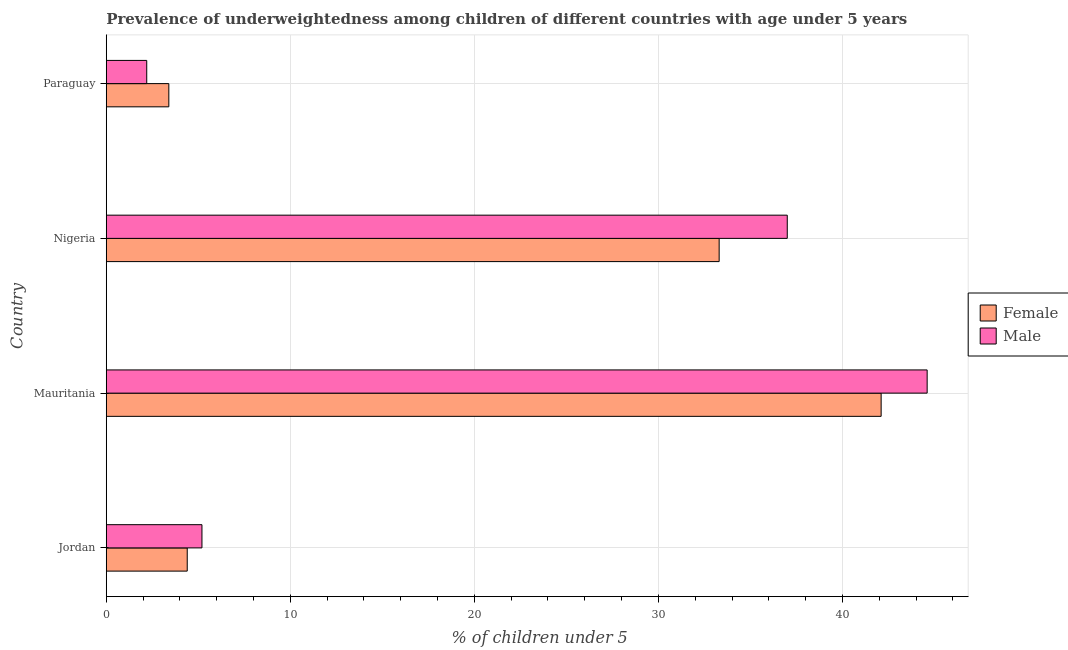What is the label of the 4th group of bars from the top?
Your answer should be compact. Jordan. What is the percentage of underweighted female children in Paraguay?
Give a very brief answer. 3.4. Across all countries, what is the maximum percentage of underweighted female children?
Offer a very short reply. 42.1. Across all countries, what is the minimum percentage of underweighted female children?
Make the answer very short. 3.4. In which country was the percentage of underweighted female children maximum?
Provide a short and direct response. Mauritania. In which country was the percentage of underweighted female children minimum?
Offer a very short reply. Paraguay. What is the total percentage of underweighted male children in the graph?
Offer a very short reply. 89. What is the difference between the percentage of underweighted female children in Jordan and that in Nigeria?
Offer a terse response. -28.9. What is the difference between the percentage of underweighted male children in Jordan and the percentage of underweighted female children in Mauritania?
Provide a succinct answer. -36.9. What is the average percentage of underweighted male children per country?
Offer a terse response. 22.25. In how many countries, is the percentage of underweighted male children greater than 32 %?
Your answer should be compact. 2. What is the ratio of the percentage of underweighted male children in Nigeria to that in Paraguay?
Ensure brevity in your answer.  16.82. Is the percentage of underweighted male children in Jordan less than that in Paraguay?
Your response must be concise. No. What is the difference between the highest and the lowest percentage of underweighted female children?
Offer a very short reply. 38.7. In how many countries, is the percentage of underweighted female children greater than the average percentage of underweighted female children taken over all countries?
Offer a terse response. 2. What does the 1st bar from the top in Jordan represents?
Your answer should be compact. Male. Are all the bars in the graph horizontal?
Give a very brief answer. Yes. How many countries are there in the graph?
Ensure brevity in your answer.  4. Does the graph contain grids?
Offer a very short reply. Yes. Where does the legend appear in the graph?
Your answer should be very brief. Center right. How many legend labels are there?
Make the answer very short. 2. How are the legend labels stacked?
Give a very brief answer. Vertical. What is the title of the graph?
Ensure brevity in your answer.  Prevalence of underweightedness among children of different countries with age under 5 years. Does "Primary income" appear as one of the legend labels in the graph?
Ensure brevity in your answer.  No. What is the label or title of the X-axis?
Your answer should be very brief.  % of children under 5. What is the  % of children under 5 of Female in Jordan?
Make the answer very short. 4.4. What is the  % of children under 5 of Male in Jordan?
Your response must be concise. 5.2. What is the  % of children under 5 of Female in Mauritania?
Give a very brief answer. 42.1. What is the  % of children under 5 of Male in Mauritania?
Offer a very short reply. 44.6. What is the  % of children under 5 of Female in Nigeria?
Provide a short and direct response. 33.3. What is the  % of children under 5 of Female in Paraguay?
Your answer should be compact. 3.4. What is the  % of children under 5 of Male in Paraguay?
Ensure brevity in your answer.  2.2. Across all countries, what is the maximum  % of children under 5 in Female?
Offer a very short reply. 42.1. Across all countries, what is the maximum  % of children under 5 in Male?
Your answer should be very brief. 44.6. Across all countries, what is the minimum  % of children under 5 of Female?
Your response must be concise. 3.4. Across all countries, what is the minimum  % of children under 5 of Male?
Your response must be concise. 2.2. What is the total  % of children under 5 of Female in the graph?
Make the answer very short. 83.2. What is the total  % of children under 5 of Male in the graph?
Keep it short and to the point. 89. What is the difference between the  % of children under 5 of Female in Jordan and that in Mauritania?
Keep it short and to the point. -37.7. What is the difference between the  % of children under 5 of Male in Jordan and that in Mauritania?
Make the answer very short. -39.4. What is the difference between the  % of children under 5 of Female in Jordan and that in Nigeria?
Offer a very short reply. -28.9. What is the difference between the  % of children under 5 of Male in Jordan and that in Nigeria?
Your answer should be very brief. -31.8. What is the difference between the  % of children under 5 of Female in Jordan and that in Paraguay?
Keep it short and to the point. 1. What is the difference between the  % of children under 5 in Male in Jordan and that in Paraguay?
Make the answer very short. 3. What is the difference between the  % of children under 5 in Female in Mauritania and that in Nigeria?
Provide a succinct answer. 8.8. What is the difference between the  % of children under 5 in Female in Mauritania and that in Paraguay?
Your answer should be compact. 38.7. What is the difference between the  % of children under 5 in Male in Mauritania and that in Paraguay?
Ensure brevity in your answer.  42.4. What is the difference between the  % of children under 5 in Female in Nigeria and that in Paraguay?
Offer a very short reply. 29.9. What is the difference between the  % of children under 5 of Male in Nigeria and that in Paraguay?
Ensure brevity in your answer.  34.8. What is the difference between the  % of children under 5 of Female in Jordan and the  % of children under 5 of Male in Mauritania?
Provide a succinct answer. -40.2. What is the difference between the  % of children under 5 in Female in Jordan and the  % of children under 5 in Male in Nigeria?
Your response must be concise. -32.6. What is the difference between the  % of children under 5 of Female in Mauritania and the  % of children under 5 of Male in Paraguay?
Your answer should be very brief. 39.9. What is the difference between the  % of children under 5 of Female in Nigeria and the  % of children under 5 of Male in Paraguay?
Provide a short and direct response. 31.1. What is the average  % of children under 5 in Female per country?
Your response must be concise. 20.8. What is the average  % of children under 5 in Male per country?
Your response must be concise. 22.25. What is the difference between the  % of children under 5 in Female and  % of children under 5 in Male in Jordan?
Offer a very short reply. -0.8. What is the difference between the  % of children under 5 in Female and  % of children under 5 in Male in Nigeria?
Provide a short and direct response. -3.7. What is the difference between the  % of children under 5 in Female and  % of children under 5 in Male in Paraguay?
Make the answer very short. 1.2. What is the ratio of the  % of children under 5 of Female in Jordan to that in Mauritania?
Your answer should be compact. 0.1. What is the ratio of the  % of children under 5 of Male in Jordan to that in Mauritania?
Provide a succinct answer. 0.12. What is the ratio of the  % of children under 5 in Female in Jordan to that in Nigeria?
Offer a very short reply. 0.13. What is the ratio of the  % of children under 5 of Male in Jordan to that in Nigeria?
Keep it short and to the point. 0.14. What is the ratio of the  % of children under 5 in Female in Jordan to that in Paraguay?
Make the answer very short. 1.29. What is the ratio of the  % of children under 5 in Male in Jordan to that in Paraguay?
Your answer should be very brief. 2.36. What is the ratio of the  % of children under 5 of Female in Mauritania to that in Nigeria?
Provide a short and direct response. 1.26. What is the ratio of the  % of children under 5 of Male in Mauritania to that in Nigeria?
Keep it short and to the point. 1.21. What is the ratio of the  % of children under 5 in Female in Mauritania to that in Paraguay?
Your answer should be very brief. 12.38. What is the ratio of the  % of children under 5 of Male in Mauritania to that in Paraguay?
Your answer should be very brief. 20.27. What is the ratio of the  % of children under 5 of Female in Nigeria to that in Paraguay?
Provide a short and direct response. 9.79. What is the ratio of the  % of children under 5 of Male in Nigeria to that in Paraguay?
Make the answer very short. 16.82. What is the difference between the highest and the second highest  % of children under 5 in Male?
Offer a terse response. 7.6. What is the difference between the highest and the lowest  % of children under 5 of Female?
Keep it short and to the point. 38.7. What is the difference between the highest and the lowest  % of children under 5 of Male?
Make the answer very short. 42.4. 